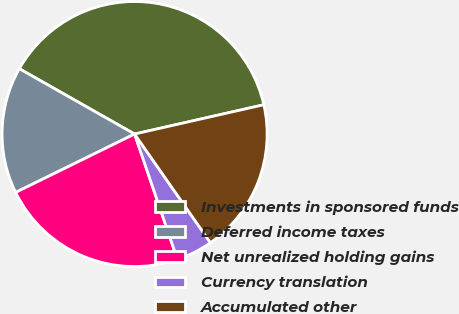Convert chart. <chart><loc_0><loc_0><loc_500><loc_500><pie_chart><fcel>Investments in sponsored funds<fcel>Deferred income taxes<fcel>Net unrealized holding gains<fcel>Currency translation<fcel>Accumulated other<nl><fcel>38.25%<fcel>15.47%<fcel>22.98%<fcel>4.46%<fcel>18.85%<nl></chart> 